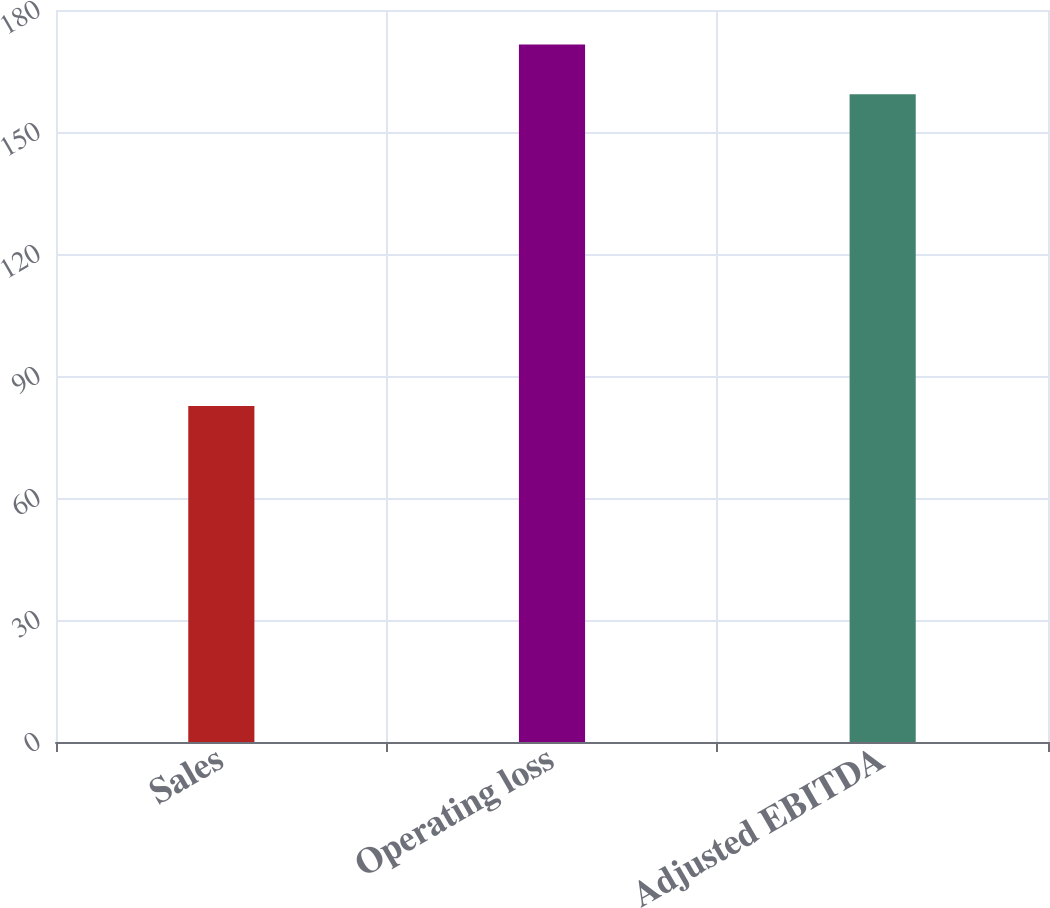Convert chart. <chart><loc_0><loc_0><loc_500><loc_500><bar_chart><fcel>Sales<fcel>Operating loss<fcel>Adjusted EBITDA<nl><fcel>82.6<fcel>171.5<fcel>159.3<nl></chart> 